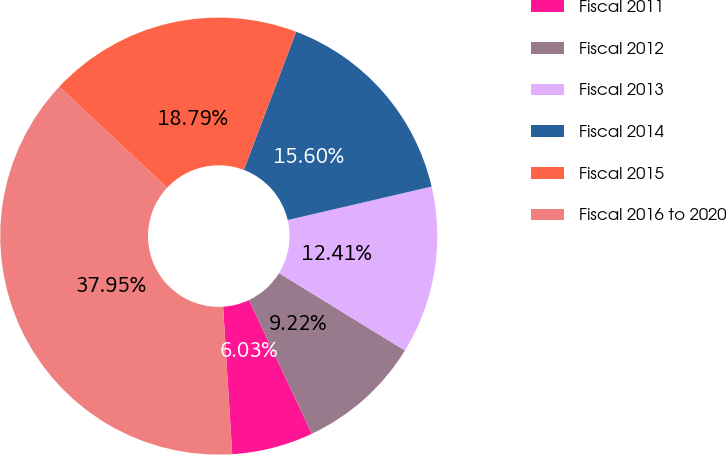Convert chart. <chart><loc_0><loc_0><loc_500><loc_500><pie_chart><fcel>Fiscal 2011<fcel>Fiscal 2012<fcel>Fiscal 2013<fcel>Fiscal 2014<fcel>Fiscal 2015<fcel>Fiscal 2016 to 2020<nl><fcel>6.03%<fcel>9.22%<fcel>12.41%<fcel>15.6%<fcel>18.79%<fcel>37.95%<nl></chart> 